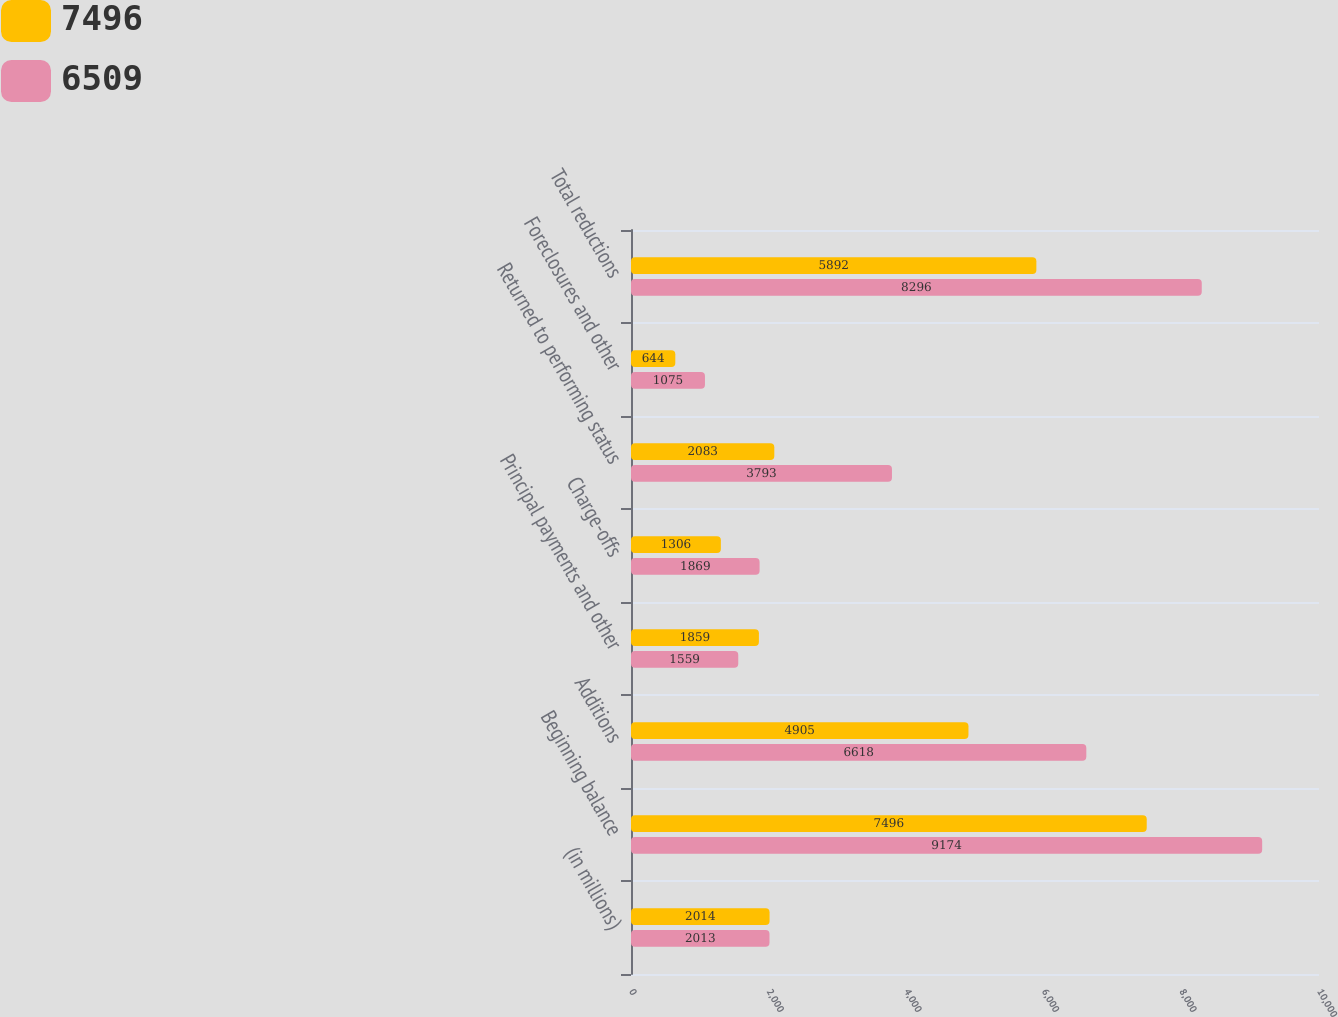Convert chart. <chart><loc_0><loc_0><loc_500><loc_500><stacked_bar_chart><ecel><fcel>(in millions)<fcel>Beginning balance<fcel>Additions<fcel>Principal payments and other<fcel>Charge-offs<fcel>Returned to performing status<fcel>Foreclosures and other<fcel>Total reductions<nl><fcel>7496<fcel>2014<fcel>7496<fcel>4905<fcel>1859<fcel>1306<fcel>2083<fcel>644<fcel>5892<nl><fcel>6509<fcel>2013<fcel>9174<fcel>6618<fcel>1559<fcel>1869<fcel>3793<fcel>1075<fcel>8296<nl></chart> 